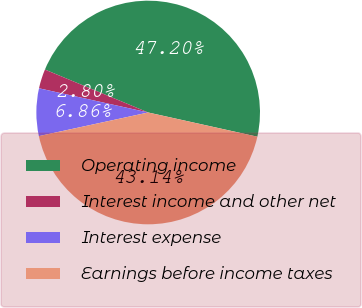Convert chart. <chart><loc_0><loc_0><loc_500><loc_500><pie_chart><fcel>Operating income<fcel>Interest income and other net<fcel>Interest expense<fcel>Earnings before income taxes<nl><fcel>47.2%<fcel>2.8%<fcel>6.86%<fcel>43.14%<nl></chart> 